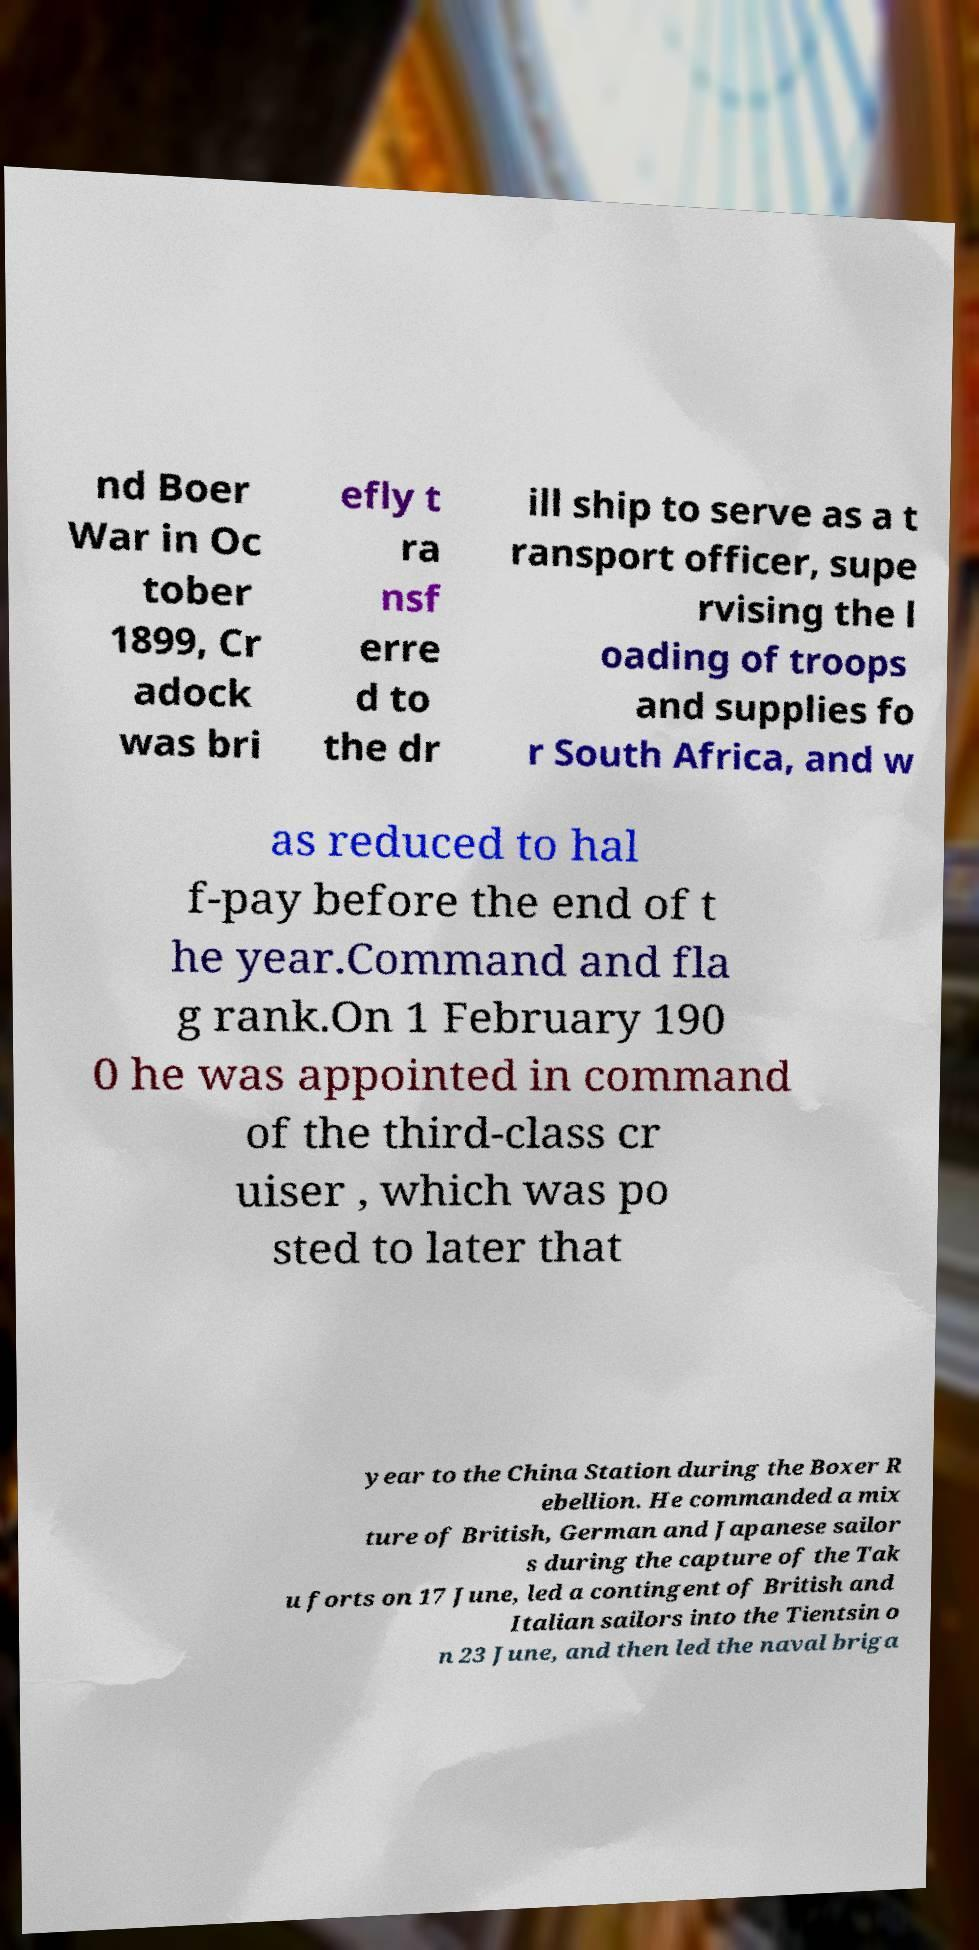What messages or text are displayed in this image? I need them in a readable, typed format. nd Boer War in Oc tober 1899, Cr adock was bri efly t ra nsf erre d to the dr ill ship to serve as a t ransport officer, supe rvising the l oading of troops and supplies fo r South Africa, and w as reduced to hal f-pay before the end of t he year.Command and fla g rank.On 1 February 190 0 he was appointed in command of the third-class cr uiser , which was po sted to later that year to the China Station during the Boxer R ebellion. He commanded a mix ture of British, German and Japanese sailor s during the capture of the Tak u forts on 17 June, led a contingent of British and Italian sailors into the Tientsin o n 23 June, and then led the naval briga 